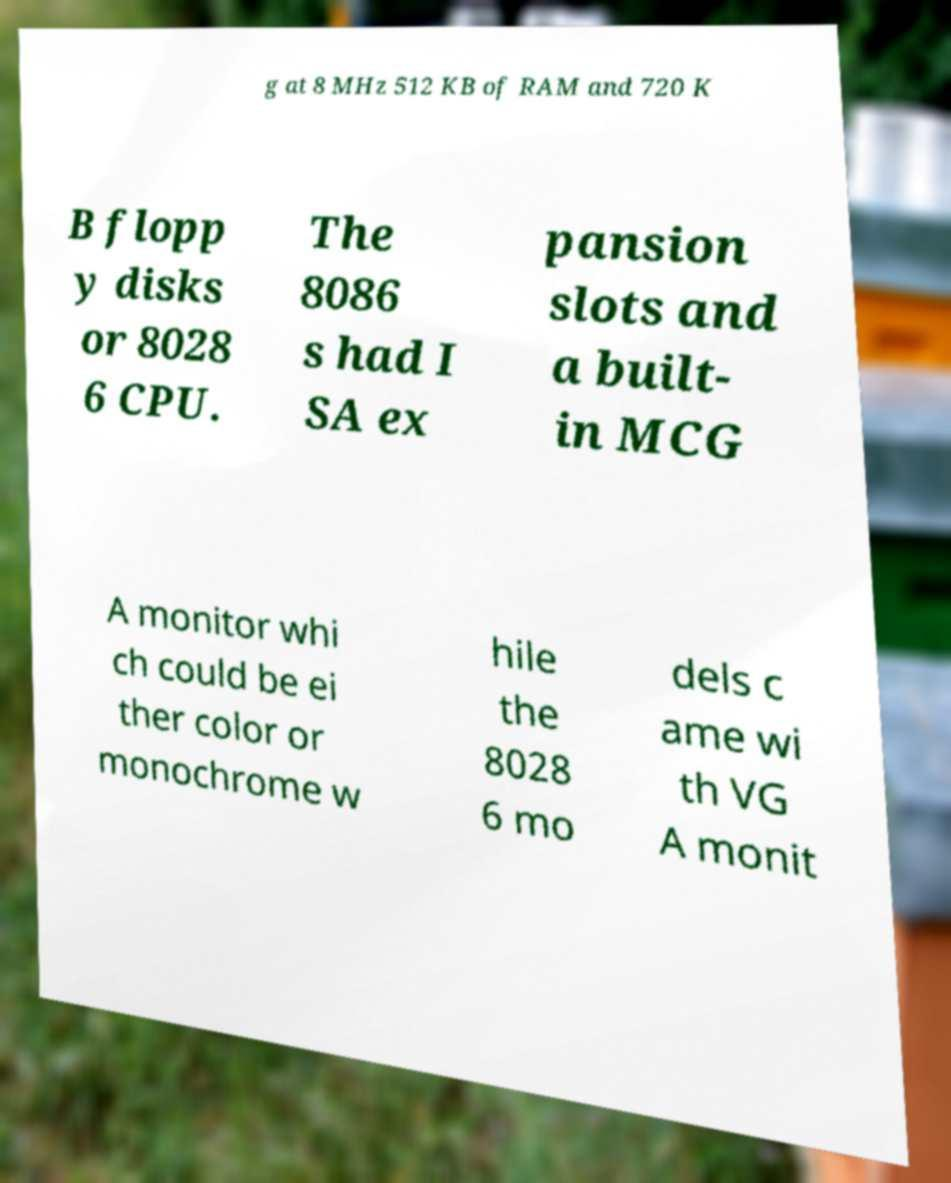Could you assist in decoding the text presented in this image and type it out clearly? g at 8 MHz 512 KB of RAM and 720 K B flopp y disks or 8028 6 CPU. The 8086 s had I SA ex pansion slots and a built- in MCG A monitor whi ch could be ei ther color or monochrome w hile the 8028 6 mo dels c ame wi th VG A monit 